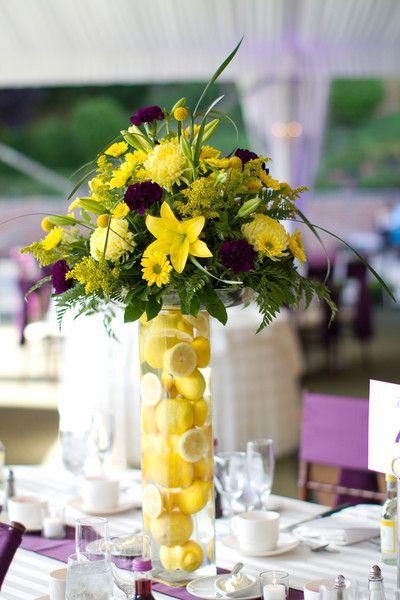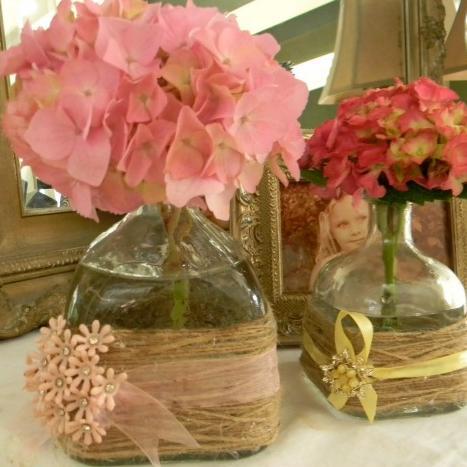The first image is the image on the left, the second image is the image on the right. Evaluate the accuracy of this statement regarding the images: "Every bottle/vase is on a table and contains at least one flower.". Is it true? Answer yes or no. Yes. 